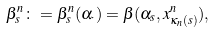Convert formula to latex. <formula><loc_0><loc_0><loc_500><loc_500>\beta ^ { n } _ { s } \colon = \beta ^ { n } _ { s } ( \alpha _ { \cdot } ) = \beta ( \alpha _ { s } , x ^ { n } _ { \kappa _ { n } ( s ) } ) ,</formula> 